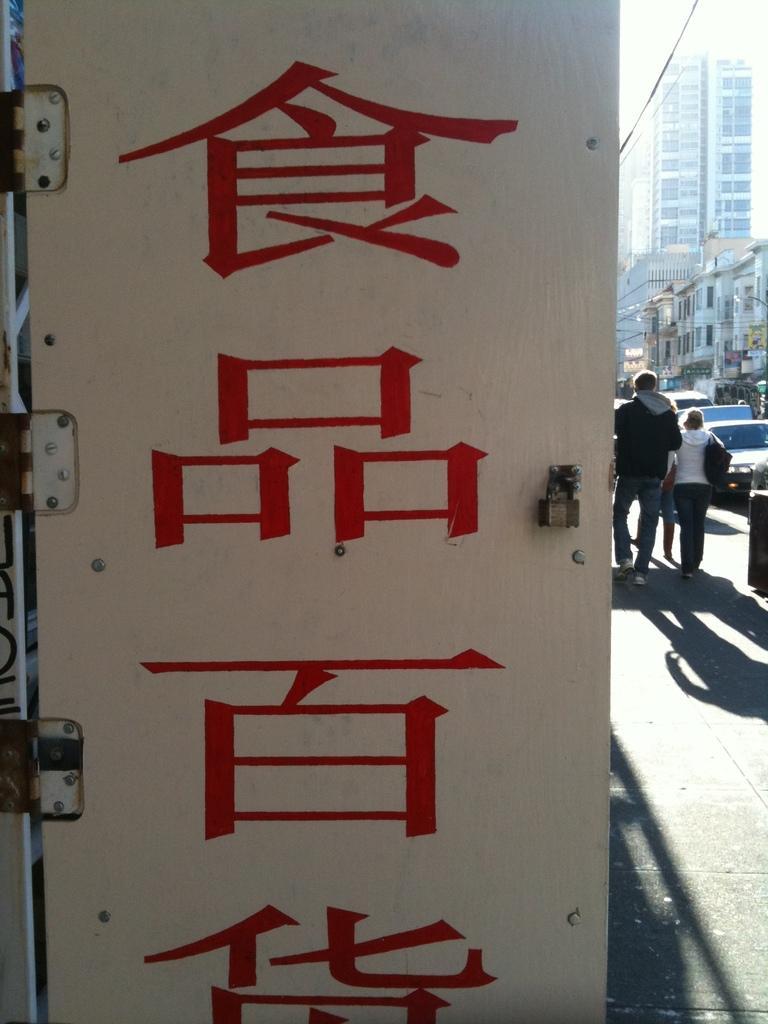Could you give a brief overview of what you see in this image? In this picture, it seems to be there is a door in the center of the image, on which there is a text and there are people, buildings, vehicles, and poles on the right side of the image. 